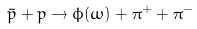Convert formula to latex. <formula><loc_0><loc_0><loc_500><loc_500>\bar { p } + p \to \phi ( \omega ) + \pi ^ { + } + \pi ^ { - }</formula> 